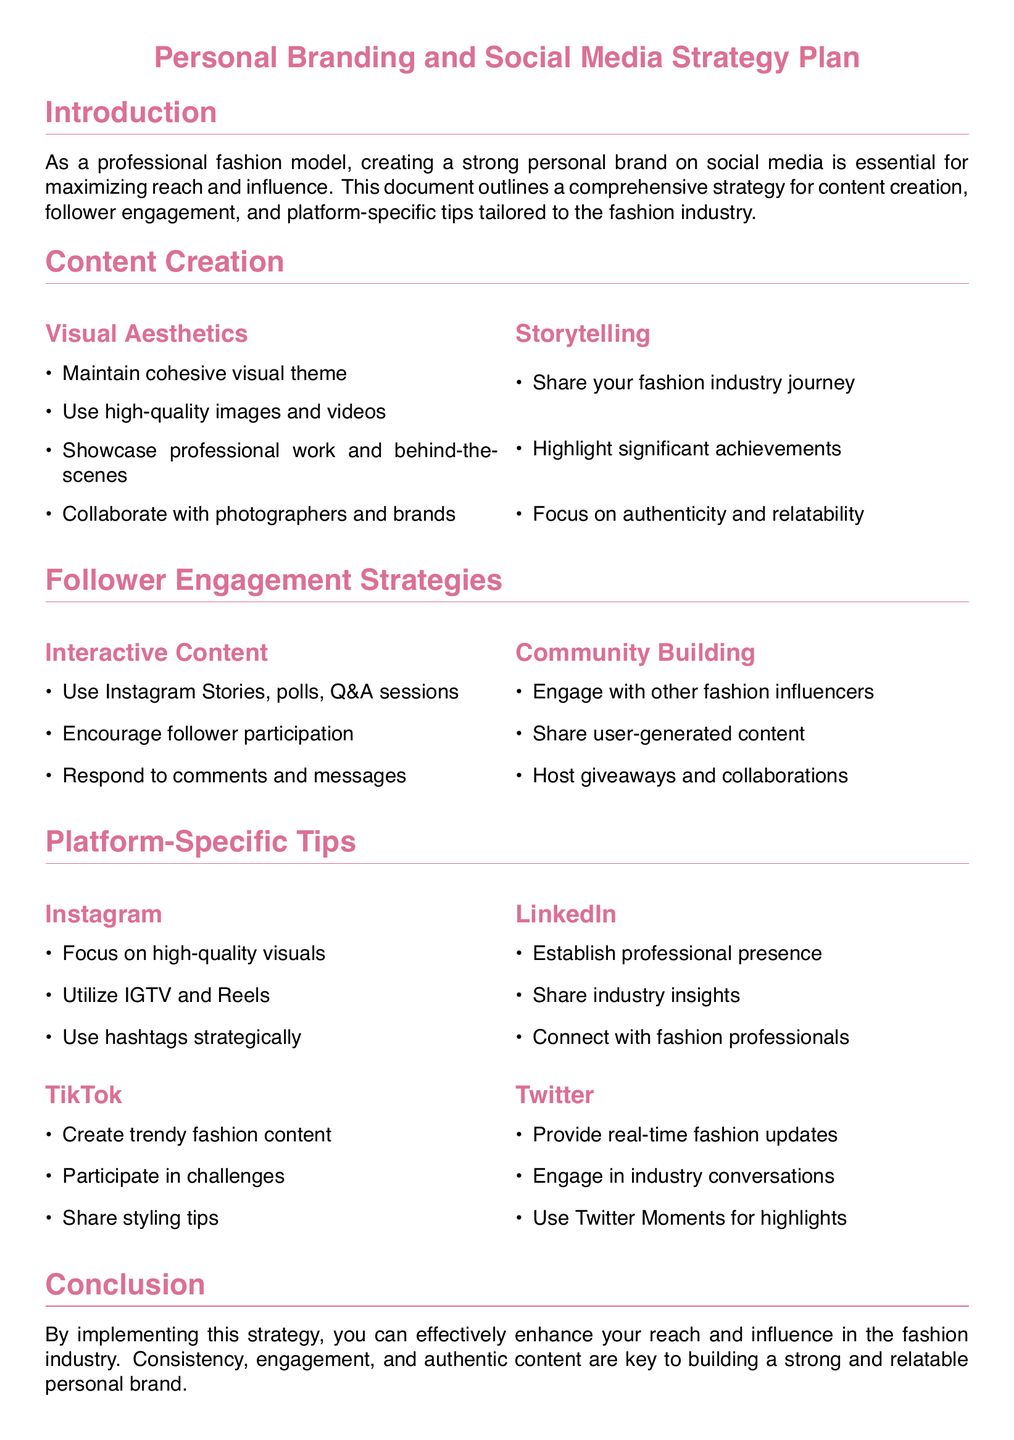What is the main purpose of the document? The document outlines a comprehensive strategy for personal branding and social media in the fashion industry.
Answer: personal branding and social media strategy How many sections are there in the content creation part? The content creation part consists of two subsections: Visual Aesthetics and Storytelling.
Answer: 2 Name two strategies for follower engagement mentioned. The document lists Interactive Content and Community Building as follower engagement strategies.
Answer: Interactive Content, Community Building Which social media platform emphasizes the use of IGTV and Reels? The document specifically mentions Instagram as the platform where IGTV and Reels are utilized.
Answer: Instagram What type of content should be created on TikTok? The document suggests creating trendy fashion content for TikTok.
Answer: trendy fashion content What is a suggested method to enhance engagement on social media? The document mentions using polls and Q&A sessions as methods to enhance engagement.
Answer: polls and Q&A sessions Which platform is recommended for establishing a professional presence? LinkedIn is recommended in the document for establishing a professional presence.
Answer: LinkedIn What color is used for the document title? The document uses a specific color defined as fashion for the title.
Answer: fashion What should the content strategy focus on according to the conclusion? The conclusion emphasizes consistency, engagement, and authentic content as key focuses.
Answer: consistency, engagement, and authentic content 